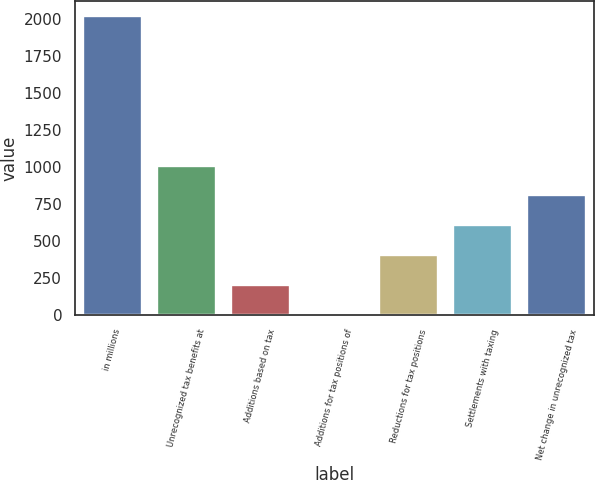<chart> <loc_0><loc_0><loc_500><loc_500><bar_chart><fcel>in millions<fcel>Unrecognized tax benefits at<fcel>Additions based on tax<fcel>Additions for tax positions of<fcel>Reductions for tax positions<fcel>Settlements with taxing<fcel>Net change in unrecognized tax<nl><fcel>2016<fcel>1009<fcel>203.4<fcel>2<fcel>404.8<fcel>606.2<fcel>807.6<nl></chart> 